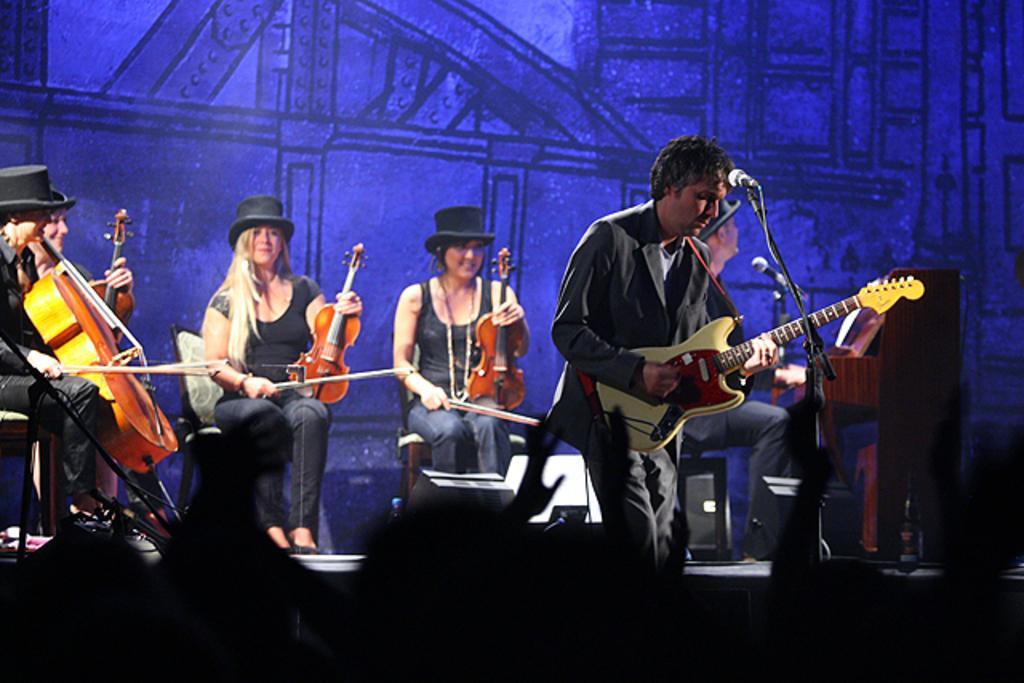What are the people on stage doing? A: The people on stage are holding guitars. What might the people on stage be using to amplify their voices? There is a microphone in the image, which could be used for amplifying their voices. What type of musical instruments are the people on stage playing? The people on stage are playing guitars. What type of animal is visible on stage in the image? There are no animals visible on stage in the image. How many knots are tied in the guitar strings in the image? The image does not show the guitar strings, so it is impossible to determine the number of knots. 